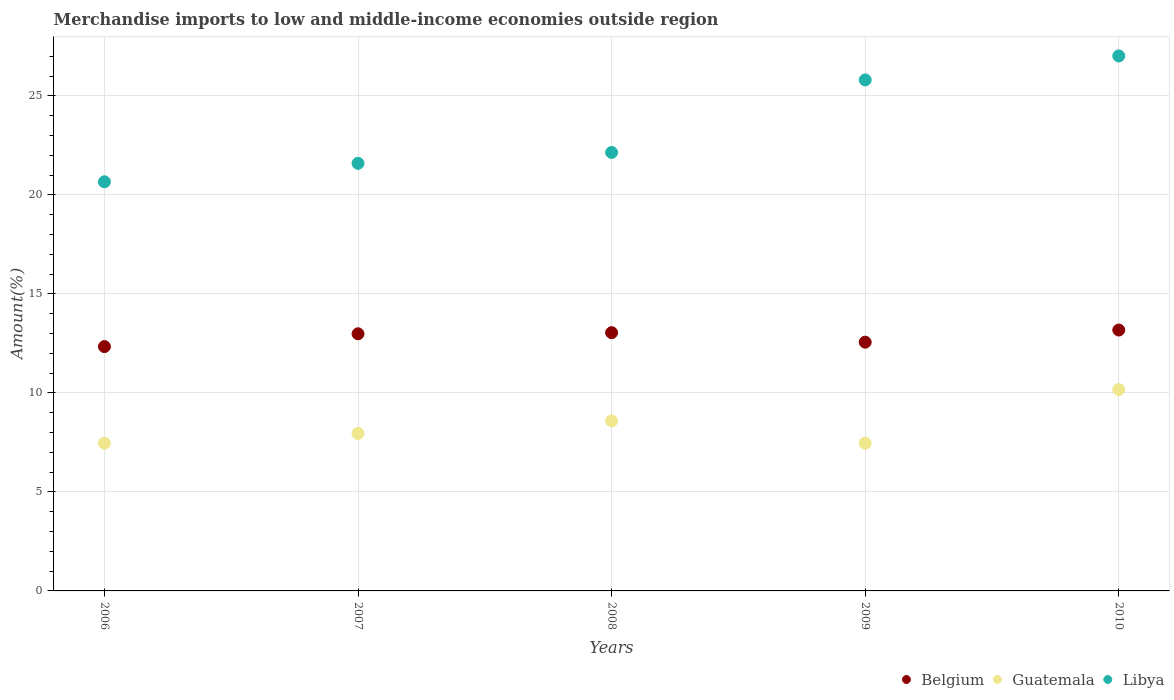How many different coloured dotlines are there?
Provide a succinct answer. 3. Is the number of dotlines equal to the number of legend labels?
Your answer should be very brief. Yes. What is the percentage of amount earned from merchandise imports in Libya in 2009?
Offer a terse response. 25.81. Across all years, what is the maximum percentage of amount earned from merchandise imports in Guatemala?
Your answer should be very brief. 10.17. Across all years, what is the minimum percentage of amount earned from merchandise imports in Libya?
Give a very brief answer. 20.66. In which year was the percentage of amount earned from merchandise imports in Guatemala maximum?
Ensure brevity in your answer.  2010. What is the total percentage of amount earned from merchandise imports in Libya in the graph?
Offer a very short reply. 117.21. What is the difference between the percentage of amount earned from merchandise imports in Guatemala in 2008 and that in 2009?
Offer a very short reply. 1.13. What is the difference between the percentage of amount earned from merchandise imports in Belgium in 2009 and the percentage of amount earned from merchandise imports in Libya in 2008?
Ensure brevity in your answer.  -9.58. What is the average percentage of amount earned from merchandise imports in Libya per year?
Offer a terse response. 23.44. In the year 2009, what is the difference between the percentage of amount earned from merchandise imports in Guatemala and percentage of amount earned from merchandise imports in Libya?
Provide a short and direct response. -18.35. In how many years, is the percentage of amount earned from merchandise imports in Libya greater than 1 %?
Your answer should be very brief. 5. What is the ratio of the percentage of amount earned from merchandise imports in Belgium in 2006 to that in 2007?
Give a very brief answer. 0.95. Is the percentage of amount earned from merchandise imports in Guatemala in 2006 less than that in 2007?
Offer a very short reply. Yes. What is the difference between the highest and the second highest percentage of amount earned from merchandise imports in Libya?
Your answer should be very brief. 1.21. What is the difference between the highest and the lowest percentage of amount earned from merchandise imports in Guatemala?
Your answer should be compact. 2.71. In how many years, is the percentage of amount earned from merchandise imports in Libya greater than the average percentage of amount earned from merchandise imports in Libya taken over all years?
Your answer should be compact. 2. Is it the case that in every year, the sum of the percentage of amount earned from merchandise imports in Guatemala and percentage of amount earned from merchandise imports in Belgium  is greater than the percentage of amount earned from merchandise imports in Libya?
Your answer should be very brief. No. Is the percentage of amount earned from merchandise imports in Libya strictly greater than the percentage of amount earned from merchandise imports in Guatemala over the years?
Ensure brevity in your answer.  Yes. How many years are there in the graph?
Your answer should be very brief. 5. What is the difference between two consecutive major ticks on the Y-axis?
Your answer should be very brief. 5. Does the graph contain grids?
Your answer should be very brief. Yes. Where does the legend appear in the graph?
Make the answer very short. Bottom right. How many legend labels are there?
Your response must be concise. 3. What is the title of the graph?
Your response must be concise. Merchandise imports to low and middle-income economies outside region. What is the label or title of the Y-axis?
Your response must be concise. Amount(%). What is the Amount(%) in Belgium in 2006?
Provide a succinct answer. 12.34. What is the Amount(%) in Guatemala in 2006?
Your answer should be very brief. 7.46. What is the Amount(%) of Libya in 2006?
Provide a short and direct response. 20.66. What is the Amount(%) in Belgium in 2007?
Your response must be concise. 12.98. What is the Amount(%) of Guatemala in 2007?
Your response must be concise. 7.95. What is the Amount(%) of Libya in 2007?
Make the answer very short. 21.59. What is the Amount(%) in Belgium in 2008?
Provide a succinct answer. 13.04. What is the Amount(%) of Guatemala in 2008?
Your response must be concise. 8.58. What is the Amount(%) of Libya in 2008?
Make the answer very short. 22.14. What is the Amount(%) in Belgium in 2009?
Provide a short and direct response. 12.56. What is the Amount(%) of Guatemala in 2009?
Provide a short and direct response. 7.46. What is the Amount(%) in Libya in 2009?
Your response must be concise. 25.81. What is the Amount(%) of Belgium in 2010?
Provide a short and direct response. 13.17. What is the Amount(%) of Guatemala in 2010?
Keep it short and to the point. 10.17. What is the Amount(%) of Libya in 2010?
Provide a succinct answer. 27.02. Across all years, what is the maximum Amount(%) of Belgium?
Make the answer very short. 13.17. Across all years, what is the maximum Amount(%) of Guatemala?
Your answer should be compact. 10.17. Across all years, what is the maximum Amount(%) in Libya?
Provide a short and direct response. 27.02. Across all years, what is the minimum Amount(%) in Belgium?
Keep it short and to the point. 12.34. Across all years, what is the minimum Amount(%) of Guatemala?
Offer a terse response. 7.46. Across all years, what is the minimum Amount(%) in Libya?
Your response must be concise. 20.66. What is the total Amount(%) of Belgium in the graph?
Your answer should be compact. 64.1. What is the total Amount(%) in Guatemala in the graph?
Your answer should be compact. 41.62. What is the total Amount(%) in Libya in the graph?
Make the answer very short. 117.21. What is the difference between the Amount(%) in Belgium in 2006 and that in 2007?
Your response must be concise. -0.65. What is the difference between the Amount(%) of Guatemala in 2006 and that in 2007?
Your answer should be very brief. -0.49. What is the difference between the Amount(%) in Libya in 2006 and that in 2007?
Your response must be concise. -0.93. What is the difference between the Amount(%) of Belgium in 2006 and that in 2008?
Give a very brief answer. -0.7. What is the difference between the Amount(%) in Guatemala in 2006 and that in 2008?
Provide a short and direct response. -1.12. What is the difference between the Amount(%) of Libya in 2006 and that in 2008?
Provide a short and direct response. -1.48. What is the difference between the Amount(%) of Belgium in 2006 and that in 2009?
Offer a very short reply. -0.22. What is the difference between the Amount(%) of Guatemala in 2006 and that in 2009?
Your response must be concise. 0. What is the difference between the Amount(%) in Libya in 2006 and that in 2009?
Provide a short and direct response. -5.14. What is the difference between the Amount(%) in Belgium in 2006 and that in 2010?
Provide a short and direct response. -0.84. What is the difference between the Amount(%) in Guatemala in 2006 and that in 2010?
Your answer should be compact. -2.71. What is the difference between the Amount(%) of Libya in 2006 and that in 2010?
Provide a succinct answer. -6.36. What is the difference between the Amount(%) in Belgium in 2007 and that in 2008?
Offer a very short reply. -0.06. What is the difference between the Amount(%) in Guatemala in 2007 and that in 2008?
Your answer should be very brief. -0.63. What is the difference between the Amount(%) in Libya in 2007 and that in 2008?
Offer a terse response. -0.55. What is the difference between the Amount(%) in Belgium in 2007 and that in 2009?
Ensure brevity in your answer.  0.42. What is the difference between the Amount(%) in Guatemala in 2007 and that in 2009?
Provide a short and direct response. 0.49. What is the difference between the Amount(%) in Libya in 2007 and that in 2009?
Provide a succinct answer. -4.21. What is the difference between the Amount(%) of Belgium in 2007 and that in 2010?
Your answer should be very brief. -0.19. What is the difference between the Amount(%) in Guatemala in 2007 and that in 2010?
Keep it short and to the point. -2.22. What is the difference between the Amount(%) of Libya in 2007 and that in 2010?
Give a very brief answer. -5.42. What is the difference between the Amount(%) in Belgium in 2008 and that in 2009?
Your response must be concise. 0.48. What is the difference between the Amount(%) of Guatemala in 2008 and that in 2009?
Offer a terse response. 1.13. What is the difference between the Amount(%) in Libya in 2008 and that in 2009?
Provide a short and direct response. -3.66. What is the difference between the Amount(%) of Belgium in 2008 and that in 2010?
Offer a very short reply. -0.13. What is the difference between the Amount(%) in Guatemala in 2008 and that in 2010?
Keep it short and to the point. -1.58. What is the difference between the Amount(%) in Libya in 2008 and that in 2010?
Offer a very short reply. -4.87. What is the difference between the Amount(%) of Belgium in 2009 and that in 2010?
Offer a very short reply. -0.61. What is the difference between the Amount(%) in Guatemala in 2009 and that in 2010?
Your answer should be compact. -2.71. What is the difference between the Amount(%) of Libya in 2009 and that in 2010?
Give a very brief answer. -1.21. What is the difference between the Amount(%) of Belgium in 2006 and the Amount(%) of Guatemala in 2007?
Give a very brief answer. 4.39. What is the difference between the Amount(%) of Belgium in 2006 and the Amount(%) of Libya in 2007?
Offer a very short reply. -9.25. What is the difference between the Amount(%) in Guatemala in 2006 and the Amount(%) in Libya in 2007?
Ensure brevity in your answer.  -14.13. What is the difference between the Amount(%) of Belgium in 2006 and the Amount(%) of Guatemala in 2008?
Your answer should be compact. 3.75. What is the difference between the Amount(%) in Belgium in 2006 and the Amount(%) in Libya in 2008?
Provide a succinct answer. -9.8. What is the difference between the Amount(%) of Guatemala in 2006 and the Amount(%) of Libya in 2008?
Offer a terse response. -14.68. What is the difference between the Amount(%) of Belgium in 2006 and the Amount(%) of Guatemala in 2009?
Offer a very short reply. 4.88. What is the difference between the Amount(%) of Belgium in 2006 and the Amount(%) of Libya in 2009?
Offer a very short reply. -13.47. What is the difference between the Amount(%) in Guatemala in 2006 and the Amount(%) in Libya in 2009?
Offer a terse response. -18.34. What is the difference between the Amount(%) in Belgium in 2006 and the Amount(%) in Guatemala in 2010?
Your answer should be very brief. 2.17. What is the difference between the Amount(%) in Belgium in 2006 and the Amount(%) in Libya in 2010?
Provide a short and direct response. -14.68. What is the difference between the Amount(%) in Guatemala in 2006 and the Amount(%) in Libya in 2010?
Provide a short and direct response. -19.55. What is the difference between the Amount(%) of Belgium in 2007 and the Amount(%) of Guatemala in 2008?
Provide a short and direct response. 4.4. What is the difference between the Amount(%) in Belgium in 2007 and the Amount(%) in Libya in 2008?
Your response must be concise. -9.16. What is the difference between the Amount(%) of Guatemala in 2007 and the Amount(%) of Libya in 2008?
Offer a terse response. -14.19. What is the difference between the Amount(%) of Belgium in 2007 and the Amount(%) of Guatemala in 2009?
Offer a terse response. 5.53. What is the difference between the Amount(%) of Belgium in 2007 and the Amount(%) of Libya in 2009?
Make the answer very short. -12.82. What is the difference between the Amount(%) of Guatemala in 2007 and the Amount(%) of Libya in 2009?
Provide a short and direct response. -17.85. What is the difference between the Amount(%) in Belgium in 2007 and the Amount(%) in Guatemala in 2010?
Provide a succinct answer. 2.82. What is the difference between the Amount(%) of Belgium in 2007 and the Amount(%) of Libya in 2010?
Your answer should be compact. -14.03. What is the difference between the Amount(%) of Guatemala in 2007 and the Amount(%) of Libya in 2010?
Provide a short and direct response. -19.06. What is the difference between the Amount(%) of Belgium in 2008 and the Amount(%) of Guatemala in 2009?
Your response must be concise. 5.58. What is the difference between the Amount(%) in Belgium in 2008 and the Amount(%) in Libya in 2009?
Give a very brief answer. -12.76. What is the difference between the Amount(%) in Guatemala in 2008 and the Amount(%) in Libya in 2009?
Keep it short and to the point. -17.22. What is the difference between the Amount(%) of Belgium in 2008 and the Amount(%) of Guatemala in 2010?
Offer a very short reply. 2.87. What is the difference between the Amount(%) of Belgium in 2008 and the Amount(%) of Libya in 2010?
Ensure brevity in your answer.  -13.97. What is the difference between the Amount(%) of Guatemala in 2008 and the Amount(%) of Libya in 2010?
Ensure brevity in your answer.  -18.43. What is the difference between the Amount(%) in Belgium in 2009 and the Amount(%) in Guatemala in 2010?
Offer a very short reply. 2.39. What is the difference between the Amount(%) in Belgium in 2009 and the Amount(%) in Libya in 2010?
Provide a short and direct response. -14.45. What is the difference between the Amount(%) in Guatemala in 2009 and the Amount(%) in Libya in 2010?
Give a very brief answer. -19.56. What is the average Amount(%) in Belgium per year?
Offer a terse response. 12.82. What is the average Amount(%) of Guatemala per year?
Offer a very short reply. 8.32. What is the average Amount(%) of Libya per year?
Keep it short and to the point. 23.44. In the year 2006, what is the difference between the Amount(%) of Belgium and Amount(%) of Guatemala?
Keep it short and to the point. 4.88. In the year 2006, what is the difference between the Amount(%) in Belgium and Amount(%) in Libya?
Ensure brevity in your answer.  -8.32. In the year 2006, what is the difference between the Amount(%) of Guatemala and Amount(%) of Libya?
Make the answer very short. -13.2. In the year 2007, what is the difference between the Amount(%) in Belgium and Amount(%) in Guatemala?
Your answer should be compact. 5.03. In the year 2007, what is the difference between the Amount(%) in Belgium and Amount(%) in Libya?
Ensure brevity in your answer.  -8.61. In the year 2007, what is the difference between the Amount(%) in Guatemala and Amount(%) in Libya?
Your answer should be very brief. -13.64. In the year 2008, what is the difference between the Amount(%) in Belgium and Amount(%) in Guatemala?
Give a very brief answer. 4.46. In the year 2008, what is the difference between the Amount(%) in Belgium and Amount(%) in Libya?
Offer a terse response. -9.1. In the year 2008, what is the difference between the Amount(%) of Guatemala and Amount(%) of Libya?
Offer a terse response. -13.56. In the year 2009, what is the difference between the Amount(%) of Belgium and Amount(%) of Guatemala?
Provide a succinct answer. 5.1. In the year 2009, what is the difference between the Amount(%) of Belgium and Amount(%) of Libya?
Give a very brief answer. -13.24. In the year 2009, what is the difference between the Amount(%) of Guatemala and Amount(%) of Libya?
Your response must be concise. -18.35. In the year 2010, what is the difference between the Amount(%) of Belgium and Amount(%) of Guatemala?
Your answer should be compact. 3.01. In the year 2010, what is the difference between the Amount(%) in Belgium and Amount(%) in Libya?
Make the answer very short. -13.84. In the year 2010, what is the difference between the Amount(%) in Guatemala and Amount(%) in Libya?
Offer a terse response. -16.85. What is the ratio of the Amount(%) of Belgium in 2006 to that in 2007?
Your response must be concise. 0.95. What is the ratio of the Amount(%) in Guatemala in 2006 to that in 2007?
Your response must be concise. 0.94. What is the ratio of the Amount(%) of Libya in 2006 to that in 2007?
Your answer should be compact. 0.96. What is the ratio of the Amount(%) in Belgium in 2006 to that in 2008?
Ensure brevity in your answer.  0.95. What is the ratio of the Amount(%) in Guatemala in 2006 to that in 2008?
Keep it short and to the point. 0.87. What is the ratio of the Amount(%) of Libya in 2006 to that in 2008?
Make the answer very short. 0.93. What is the ratio of the Amount(%) of Belgium in 2006 to that in 2009?
Provide a succinct answer. 0.98. What is the ratio of the Amount(%) of Libya in 2006 to that in 2009?
Offer a very short reply. 0.8. What is the ratio of the Amount(%) in Belgium in 2006 to that in 2010?
Your answer should be compact. 0.94. What is the ratio of the Amount(%) of Guatemala in 2006 to that in 2010?
Offer a very short reply. 0.73. What is the ratio of the Amount(%) of Libya in 2006 to that in 2010?
Provide a short and direct response. 0.76. What is the ratio of the Amount(%) of Guatemala in 2007 to that in 2008?
Offer a terse response. 0.93. What is the ratio of the Amount(%) in Libya in 2007 to that in 2008?
Provide a short and direct response. 0.98. What is the ratio of the Amount(%) of Belgium in 2007 to that in 2009?
Offer a terse response. 1.03. What is the ratio of the Amount(%) of Guatemala in 2007 to that in 2009?
Give a very brief answer. 1.07. What is the ratio of the Amount(%) in Libya in 2007 to that in 2009?
Your answer should be very brief. 0.84. What is the ratio of the Amount(%) of Belgium in 2007 to that in 2010?
Offer a very short reply. 0.99. What is the ratio of the Amount(%) in Guatemala in 2007 to that in 2010?
Your answer should be compact. 0.78. What is the ratio of the Amount(%) of Libya in 2007 to that in 2010?
Provide a succinct answer. 0.8. What is the ratio of the Amount(%) in Belgium in 2008 to that in 2009?
Give a very brief answer. 1.04. What is the ratio of the Amount(%) in Guatemala in 2008 to that in 2009?
Give a very brief answer. 1.15. What is the ratio of the Amount(%) of Libya in 2008 to that in 2009?
Provide a short and direct response. 0.86. What is the ratio of the Amount(%) of Belgium in 2008 to that in 2010?
Your answer should be compact. 0.99. What is the ratio of the Amount(%) of Guatemala in 2008 to that in 2010?
Your answer should be compact. 0.84. What is the ratio of the Amount(%) of Libya in 2008 to that in 2010?
Give a very brief answer. 0.82. What is the ratio of the Amount(%) in Belgium in 2009 to that in 2010?
Offer a terse response. 0.95. What is the ratio of the Amount(%) of Guatemala in 2009 to that in 2010?
Give a very brief answer. 0.73. What is the ratio of the Amount(%) in Libya in 2009 to that in 2010?
Provide a succinct answer. 0.96. What is the difference between the highest and the second highest Amount(%) of Belgium?
Your answer should be compact. 0.13. What is the difference between the highest and the second highest Amount(%) of Guatemala?
Provide a short and direct response. 1.58. What is the difference between the highest and the second highest Amount(%) in Libya?
Your answer should be compact. 1.21. What is the difference between the highest and the lowest Amount(%) in Belgium?
Your response must be concise. 0.84. What is the difference between the highest and the lowest Amount(%) in Guatemala?
Ensure brevity in your answer.  2.71. What is the difference between the highest and the lowest Amount(%) in Libya?
Your response must be concise. 6.36. 